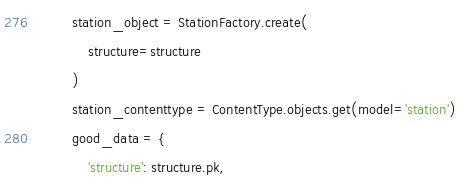<code> <loc_0><loc_0><loc_500><loc_500><_Python_>        station_object = StationFactory.create(
            structure=structure
        )
        station_contenttype = ContentType.objects.get(model='station')
        good_data = {
            'structure': structure.pk,</code> 